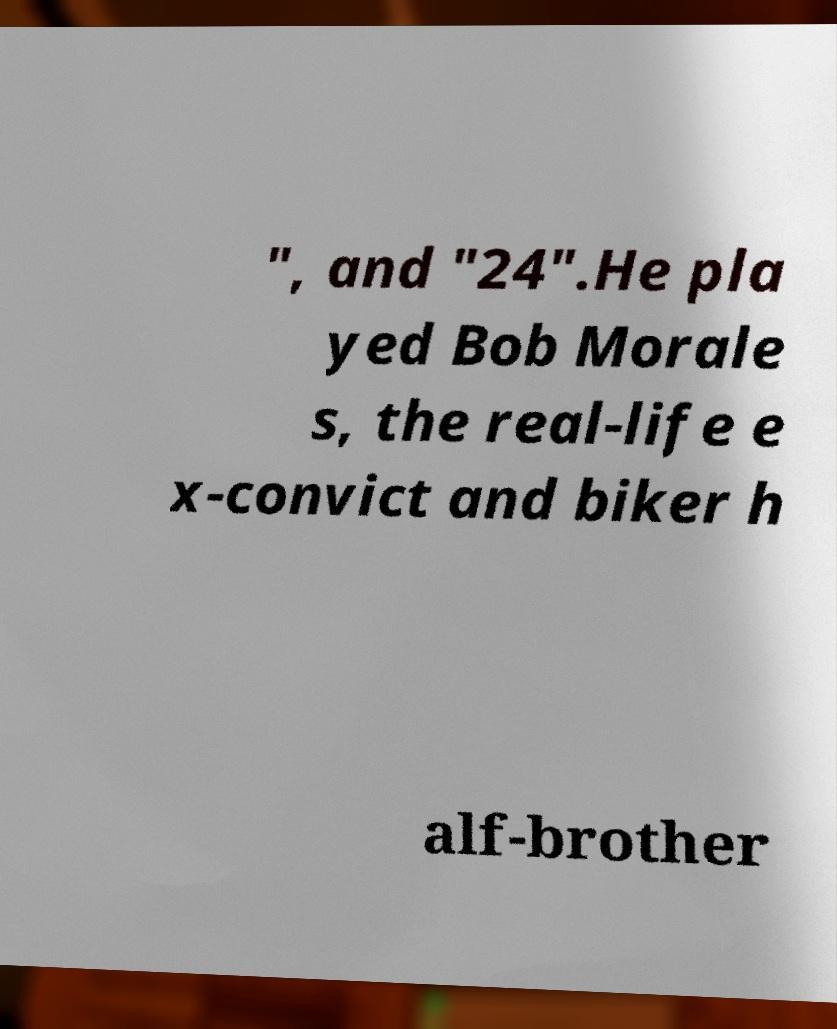There's text embedded in this image that I need extracted. Can you transcribe it verbatim? ", and "24".He pla yed Bob Morale s, the real-life e x-convict and biker h alf-brother 